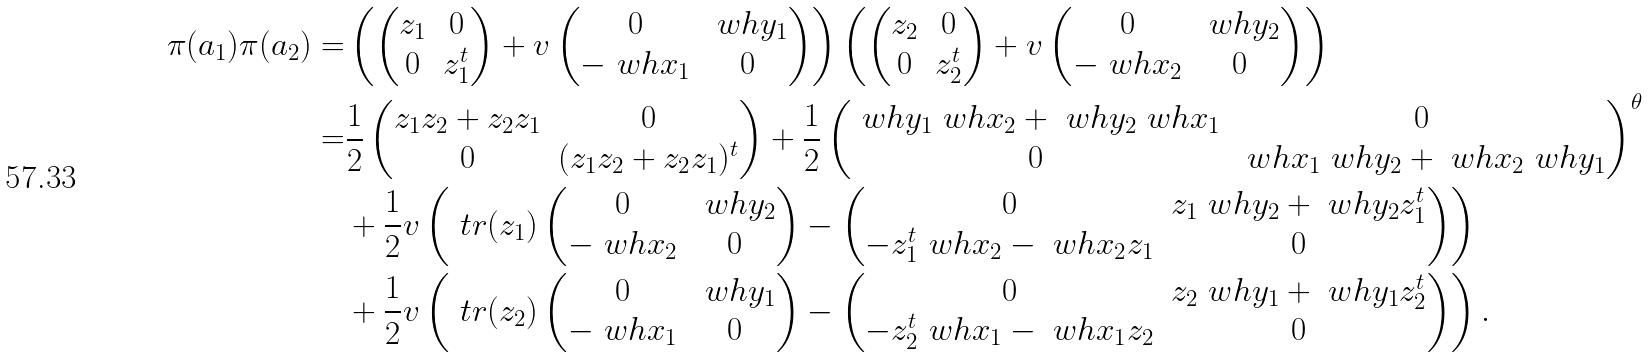Convert formula to latex. <formula><loc_0><loc_0><loc_500><loc_500>\pi ( a _ { 1 } ) \pi ( a _ { 2 } ) = & \left ( \begin{pmatrix} z _ { 1 } & 0 \\ 0 & z _ { 1 } ^ { t } \end{pmatrix} + v \begin{pmatrix} 0 & \ w h { y } _ { 1 } \\ - \ w h { x } _ { 1 } & 0 \end{pmatrix} \right ) \left ( \begin{pmatrix} z _ { 2 } & 0 \\ 0 & z _ { 2 } ^ { t } \end{pmatrix} + v \begin{pmatrix} 0 & \ w h { y } _ { 2 } \\ - \ w h { x } _ { 2 } & 0 \end{pmatrix} \right ) \\ = & \frac { 1 } { 2 } \begin{pmatrix} z _ { 1 } z _ { 2 } + z _ { 2 } z _ { 1 } & 0 \\ 0 & ( z _ { 1 } z _ { 2 } + z _ { 2 } z _ { 1 } ) ^ { t } \end{pmatrix} + \frac { 1 } { 2 } \begin{pmatrix} \ w h { y } _ { 1 } \ w h { x } _ { 2 } + \ w h { y } _ { 2 } \ w h { x } _ { 1 } & 0 \\ 0 & \ w h { x } _ { 1 } \ w h { y } _ { 2 } + \ w h { x } _ { 2 } \ w h { y } _ { 1 } \end{pmatrix} ^ { \theta } \\ & + \frac { 1 } { 2 } v \left ( \ t r ( z _ { 1 } ) \begin{pmatrix} 0 & \ w h { y } _ { 2 } \\ - \ w h { x } _ { 2 } & 0 \end{pmatrix} - \begin{pmatrix} 0 & z _ { 1 } \ w h { y } _ { 2 } + \ w h { y } _ { 2 } z _ { 1 } ^ { t } \\ - z _ { 1 } ^ { t } \ w h { x } _ { 2 } - \ w h { x } _ { 2 } z _ { 1 } & 0 \end{pmatrix} \right ) \\ & + \frac { 1 } { 2 } v \left ( \ t r ( z _ { 2 } ) \begin{pmatrix} 0 & \ w h { y } _ { 1 } \\ - \ w h { x } _ { 1 } & 0 \end{pmatrix} - \begin{pmatrix} 0 & z _ { 2 } \ w h { y } _ { 1 } + \ w h { y } _ { 1 } z _ { 2 } ^ { t } \\ - z _ { 2 } ^ { t } \ w h { x } _ { 1 } - \ w h { x } _ { 1 } z _ { 2 } & 0 \end{pmatrix} \right ) .</formula> 